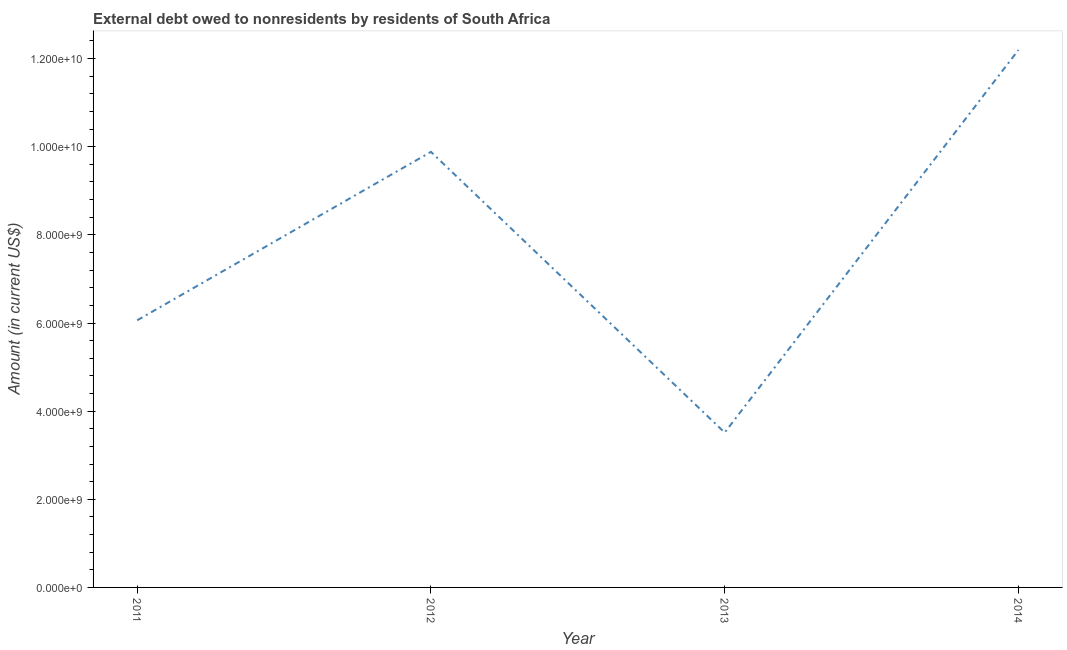What is the debt in 2014?
Offer a terse response. 1.22e+1. Across all years, what is the maximum debt?
Make the answer very short. 1.22e+1. Across all years, what is the minimum debt?
Give a very brief answer. 3.51e+09. What is the sum of the debt?
Offer a terse response. 3.17e+1. What is the difference between the debt in 2011 and 2014?
Give a very brief answer. -6.13e+09. What is the average debt per year?
Provide a succinct answer. 7.91e+09. What is the median debt?
Keep it short and to the point. 7.97e+09. In how many years, is the debt greater than 3200000000 US$?
Your answer should be very brief. 4. Do a majority of the years between 2011 and 2012 (inclusive) have debt greater than 6400000000 US$?
Your answer should be very brief. No. What is the ratio of the debt in 2012 to that in 2014?
Ensure brevity in your answer.  0.81. Is the debt in 2011 less than that in 2013?
Offer a terse response. No. What is the difference between the highest and the second highest debt?
Make the answer very short. 2.31e+09. Is the sum of the debt in 2011 and 2014 greater than the maximum debt across all years?
Your response must be concise. Yes. What is the difference between the highest and the lowest debt?
Provide a short and direct response. 8.68e+09. In how many years, is the debt greater than the average debt taken over all years?
Keep it short and to the point. 2. Does the debt monotonically increase over the years?
Give a very brief answer. No. Are the values on the major ticks of Y-axis written in scientific E-notation?
Offer a very short reply. Yes. What is the title of the graph?
Ensure brevity in your answer.  External debt owed to nonresidents by residents of South Africa. What is the Amount (in current US$) of 2011?
Give a very brief answer. 6.06e+09. What is the Amount (in current US$) in 2012?
Provide a succinct answer. 9.88e+09. What is the Amount (in current US$) of 2013?
Make the answer very short. 3.51e+09. What is the Amount (in current US$) of 2014?
Ensure brevity in your answer.  1.22e+1. What is the difference between the Amount (in current US$) in 2011 and 2012?
Offer a terse response. -3.82e+09. What is the difference between the Amount (in current US$) in 2011 and 2013?
Give a very brief answer. 2.55e+09. What is the difference between the Amount (in current US$) in 2011 and 2014?
Provide a succinct answer. -6.13e+09. What is the difference between the Amount (in current US$) in 2012 and 2013?
Offer a very short reply. 6.37e+09. What is the difference between the Amount (in current US$) in 2012 and 2014?
Keep it short and to the point. -2.31e+09. What is the difference between the Amount (in current US$) in 2013 and 2014?
Your answer should be compact. -8.68e+09. What is the ratio of the Amount (in current US$) in 2011 to that in 2012?
Your answer should be very brief. 0.61. What is the ratio of the Amount (in current US$) in 2011 to that in 2013?
Make the answer very short. 1.73. What is the ratio of the Amount (in current US$) in 2011 to that in 2014?
Offer a terse response. 0.5. What is the ratio of the Amount (in current US$) in 2012 to that in 2013?
Provide a succinct answer. 2.81. What is the ratio of the Amount (in current US$) in 2012 to that in 2014?
Your answer should be compact. 0.81. What is the ratio of the Amount (in current US$) in 2013 to that in 2014?
Your answer should be very brief. 0.29. 